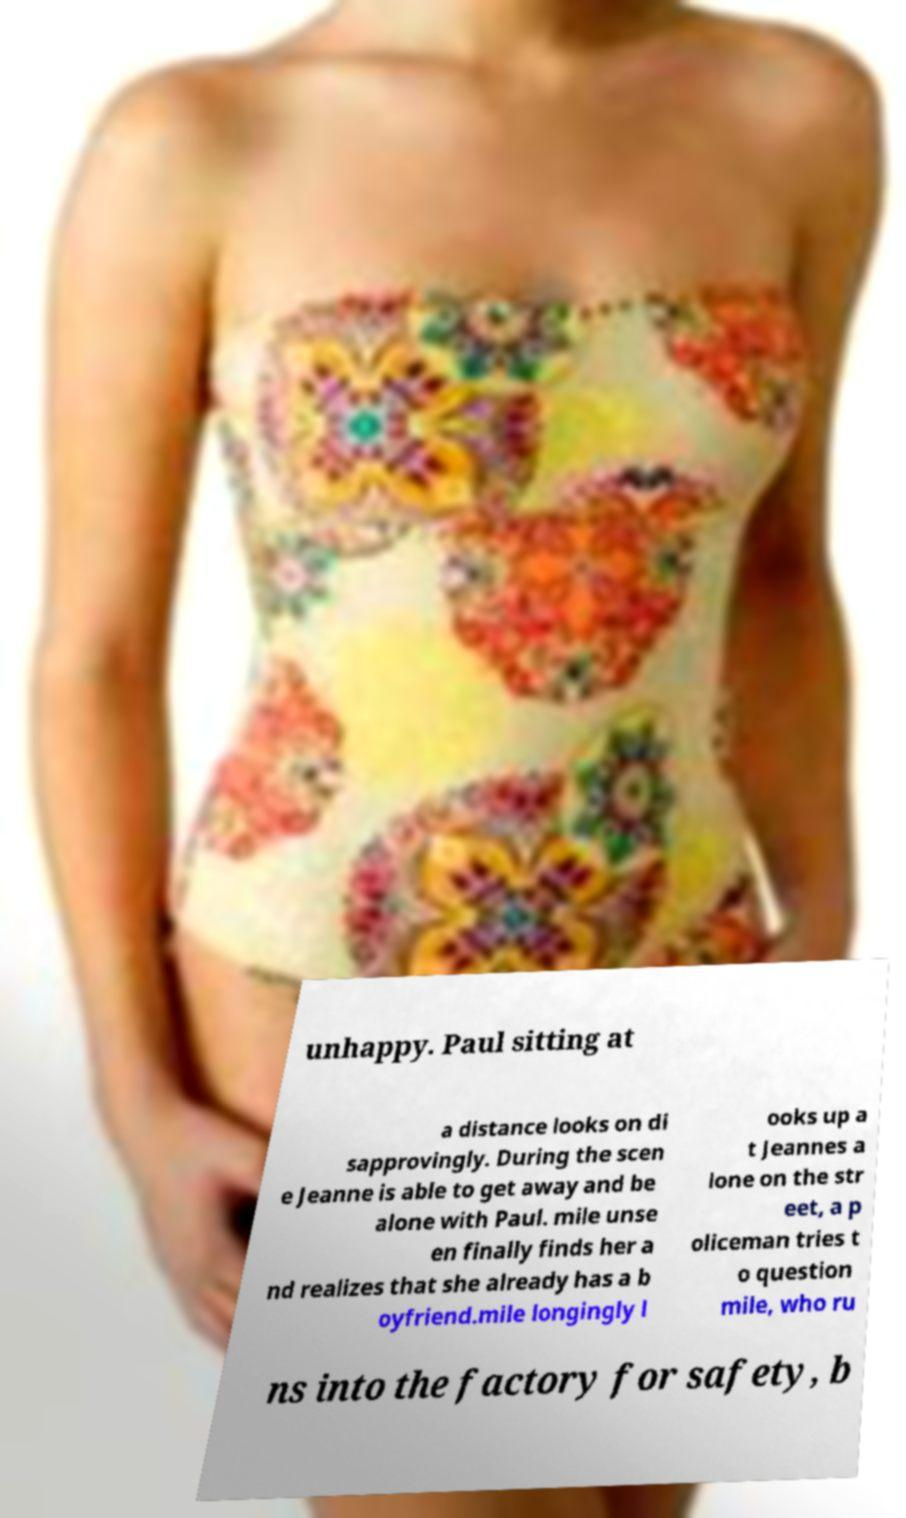Please identify and transcribe the text found in this image. unhappy. Paul sitting at a distance looks on di sapprovingly. During the scen e Jeanne is able to get away and be alone with Paul. mile unse en finally finds her a nd realizes that she already has a b oyfriend.mile longingly l ooks up a t Jeannes a lone on the str eet, a p oliceman tries t o question mile, who ru ns into the factory for safety, b 